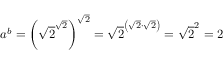Convert formula to latex. <formula><loc_0><loc_0><loc_500><loc_500>a ^ { b } = \left ( { \sqrt { 2 } } ^ { \sqrt { 2 } } \right ) ^ { \sqrt { 2 } } = { \sqrt { 2 } } ^ { \left ( { \sqrt { 2 } } \cdot { \sqrt { 2 } } \right ) } = { \sqrt { 2 } } ^ { 2 } = 2</formula> 